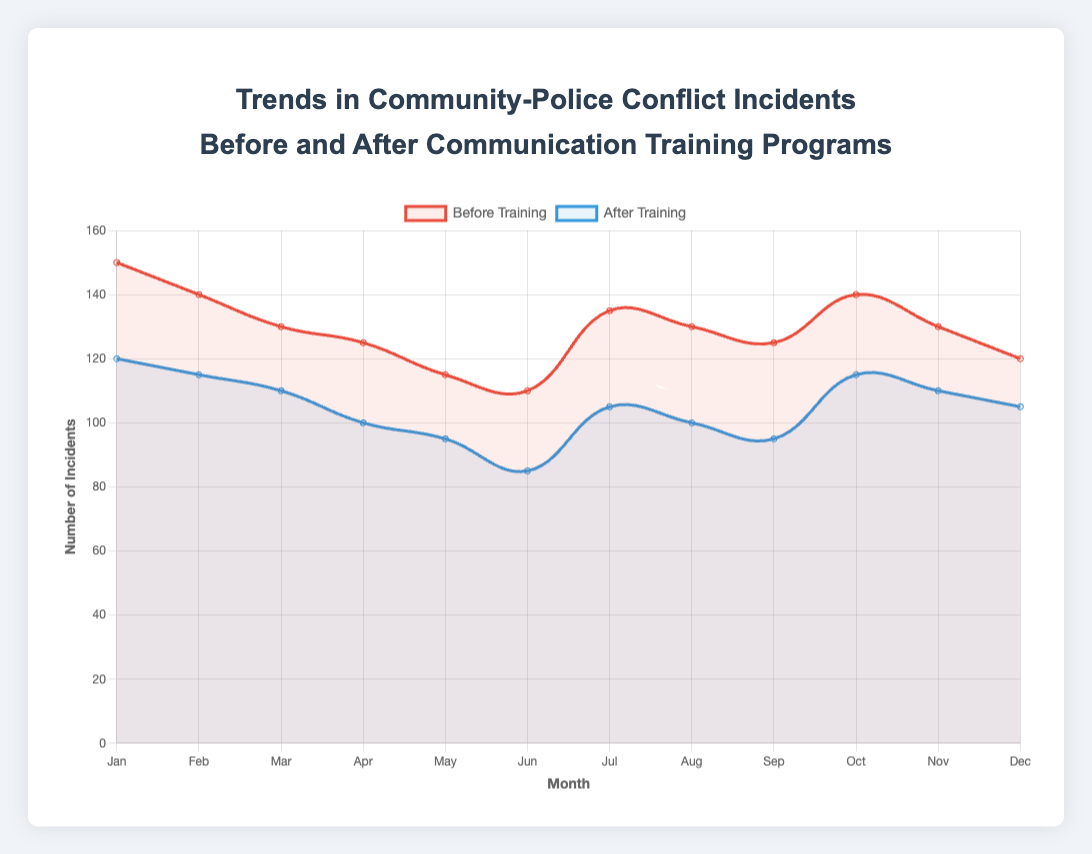What's the difference between the number of incidents before and after the training program in January? Look at the data points for January. Before training, there were 150 incidents, and after training, there were 120. The difference is 150 - 120.
Answer: 30 How did the incident count in February compare to March before the training? Look at the data points for February and March before the training. There were 140 incidents in February and 130 in March. February had more incidents.
Answer: February had more incidents Which month shows the greatest decrease in incidents after the training program? Calculate the difference between the number of incidents before and after the training for each month. The greatest difference is found in June: 110 incidents before and 85 after, a decrease of 25.
Answer: June How does the trend of incidents after the training program compare to before the training program across the year? Observe the lines representing 'Before Training' and 'After Training' across the months. The 'After Training' line consistently shows fewer incidents compared to the 'Before Training' line, indicating a downward trend post-training.
Answer: Incidents decreased after the training What is the average number of incidents after the training program? Add the number of incidents for each month after the training and divide by the number of months: (120 + 115 + 110 + 100 + 95 + 85 + 105 + 100 + 95 + 115 + 110 + 105)/12 =  making a total of 1255, so the average is 1255/12 = 104.6
Answer: 104.6 In which month was the disparity between incidents before and after the training the smallest? Calculate the difference between the incidents before and after training for each month. The smallest difference appears in November with a disparity of 20 (130 before - 110 after).
Answer: November How does the incident count in July compare between before and after the training? Look at the data points for July before (135) and after (105) the training. The incident count before training was higher than after.
Answer: Higher before training Which month had the highest number of incidents before training? Compare the 'Before Training' data across all months. January had the highest number of incidents before training, with 150.
Answer: January Compare the decrease in incidents in New York from January to March to the decrease in Los Angeles from April to June. Calculate the decrease in each city: New York from January to March: 150 - 110 = 40, Los Angeles from April to June: 125 - 85 = 40. The decreases are equal.
Answer: The decreases are equal How many more incidents did Houston have in November after the training compared to Los Angeles in May after the training? Look at the data points: Houston in November had 110 incidents and Los Angeles in May had 95 incidents. The difference is 110 - 95.
Answer: 15 